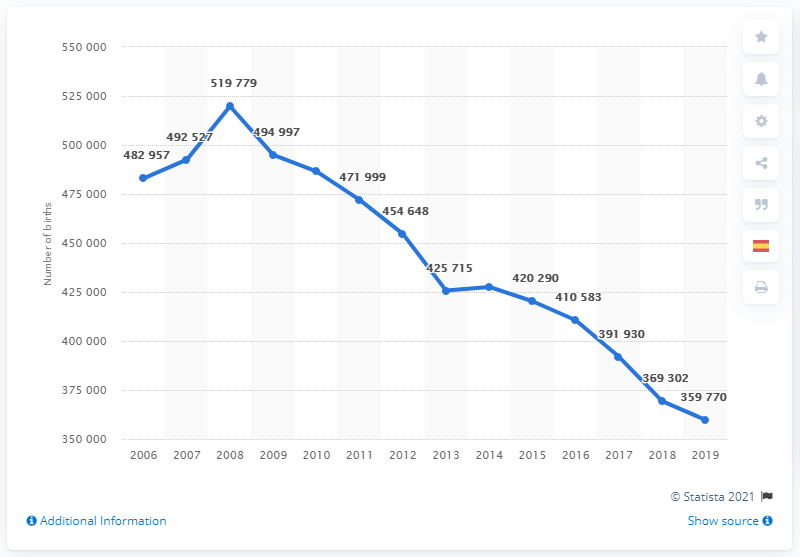Point out several critical features in this image. In 2008, it is estimated that 369,302 babies were born. In 2008, there were 519,779 births in Spain. There were 427,595 deaths in Spain in 2018. From 2007 to 2010, the average number of births in Spain was approximately 494,825.5. In 2018, a total of 369,302 newborns were born in Spain. 